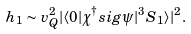<formula> <loc_0><loc_0><loc_500><loc_500>h _ { 1 } \sim v _ { Q } ^ { 2 } | \langle 0 | \chi ^ { \dagger } s i g \psi | ^ { 3 } S _ { 1 } \rangle | ^ { 2 } .</formula> 